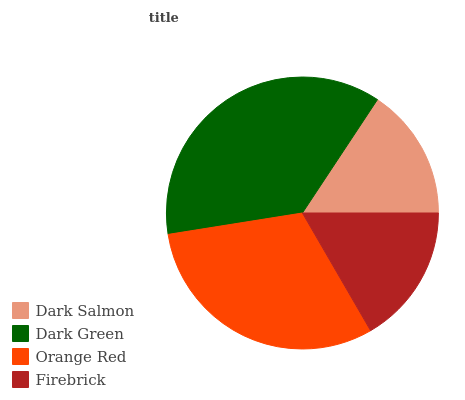Is Dark Salmon the minimum?
Answer yes or no. Yes. Is Dark Green the maximum?
Answer yes or no. Yes. Is Orange Red the minimum?
Answer yes or no. No. Is Orange Red the maximum?
Answer yes or no. No. Is Dark Green greater than Orange Red?
Answer yes or no. Yes. Is Orange Red less than Dark Green?
Answer yes or no. Yes. Is Orange Red greater than Dark Green?
Answer yes or no. No. Is Dark Green less than Orange Red?
Answer yes or no. No. Is Orange Red the high median?
Answer yes or no. Yes. Is Firebrick the low median?
Answer yes or no. Yes. Is Dark Salmon the high median?
Answer yes or no. No. Is Orange Red the low median?
Answer yes or no. No. 